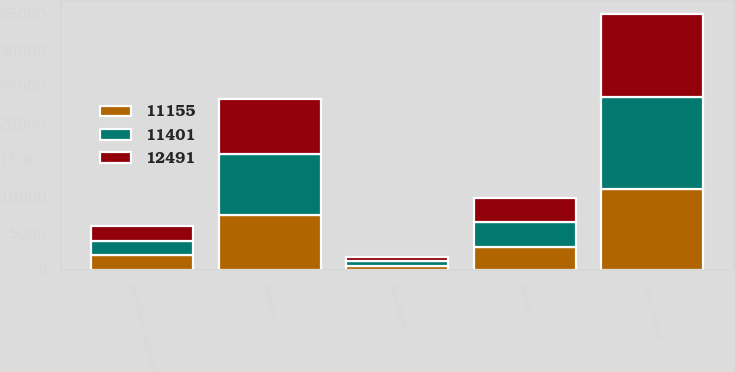<chart> <loc_0><loc_0><loc_500><loc_500><stacked_bar_chart><ecel><fcel>(in millions) Revenue<fcel>Americas<fcel>Europe<fcel>Asia-Pacific<fcel>Total revenue<nl><fcel>11401<fcel>2017<fcel>8406<fcel>3432<fcel>653<fcel>12491<nl><fcel>11155<fcel>2016<fcel>7530<fcel>3083<fcel>542<fcel>11155<nl><fcel>12491<fcel>2015<fcel>7502<fcel>3356<fcel>543<fcel>11401<nl></chart> 